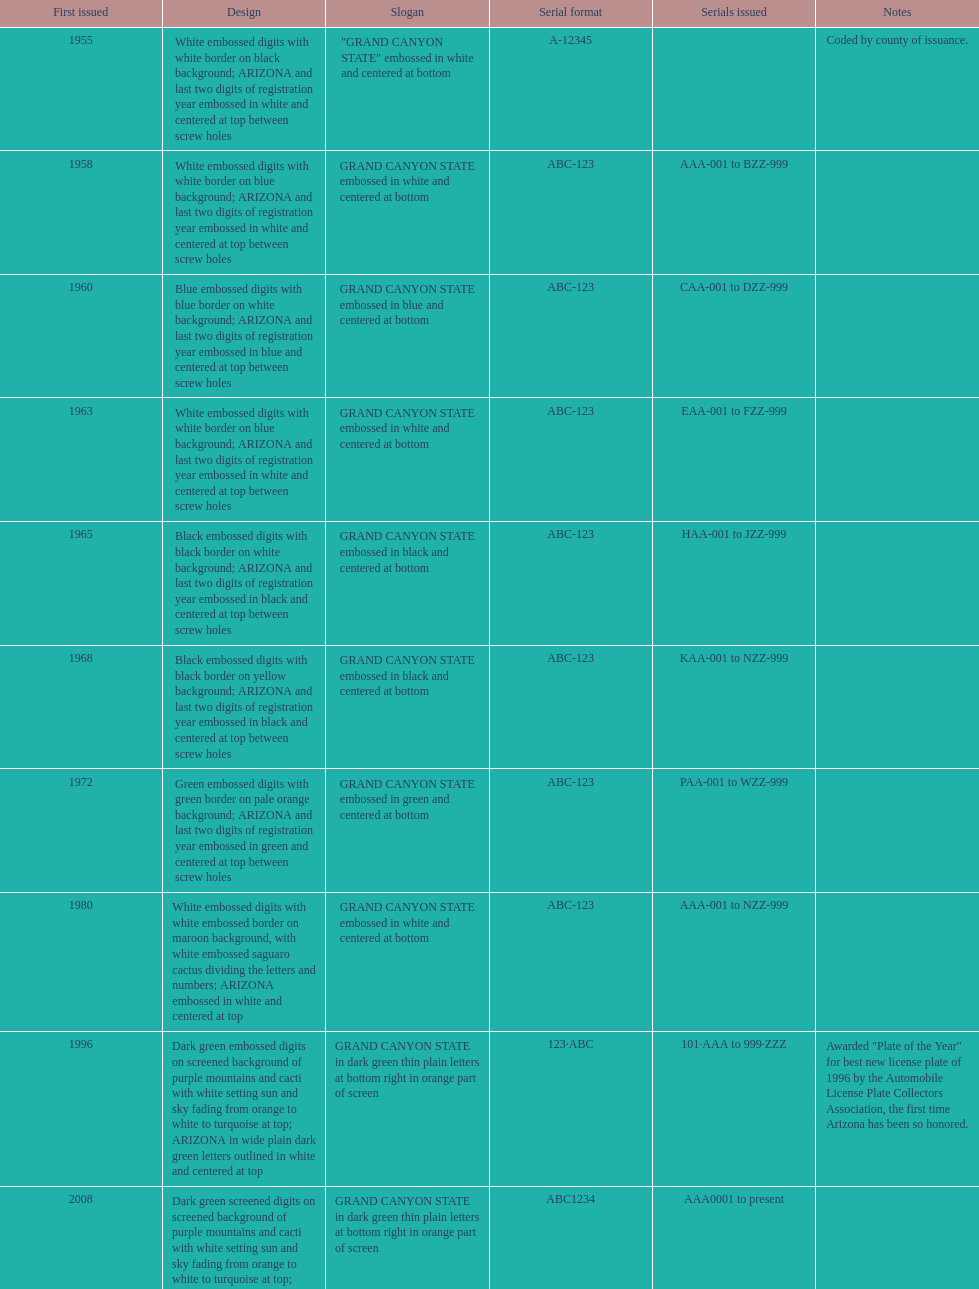What is the year of the license plate possessing the greatest quantity of alphanumeric digits? 2008. 